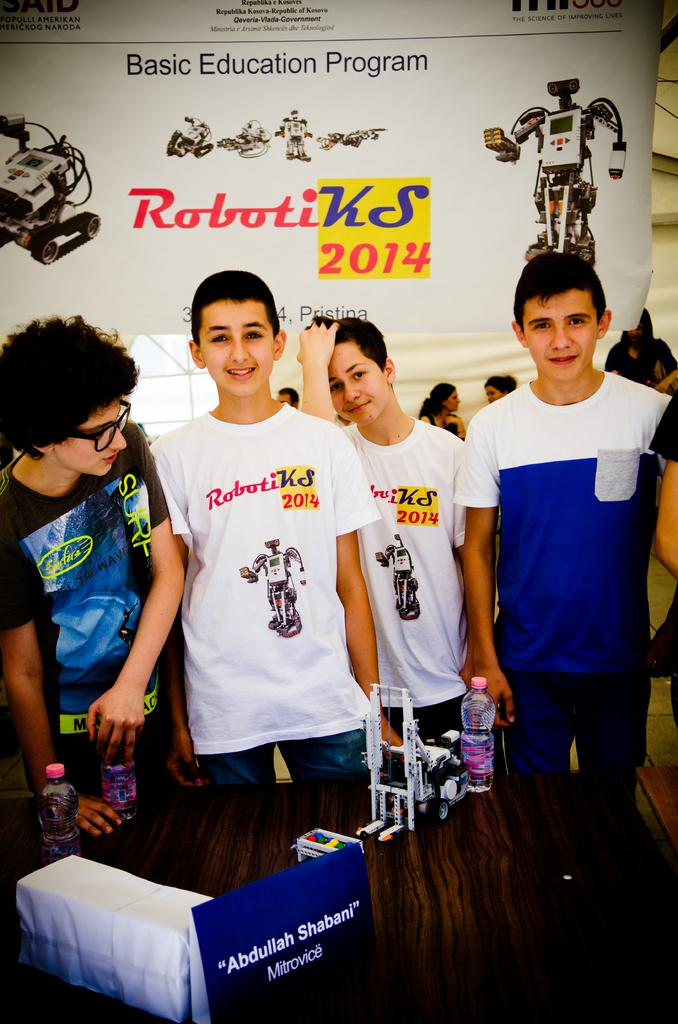Provide a one-sentence caption for the provided image. Some boys standing in front of a sign that says Roboti KS 2014. 